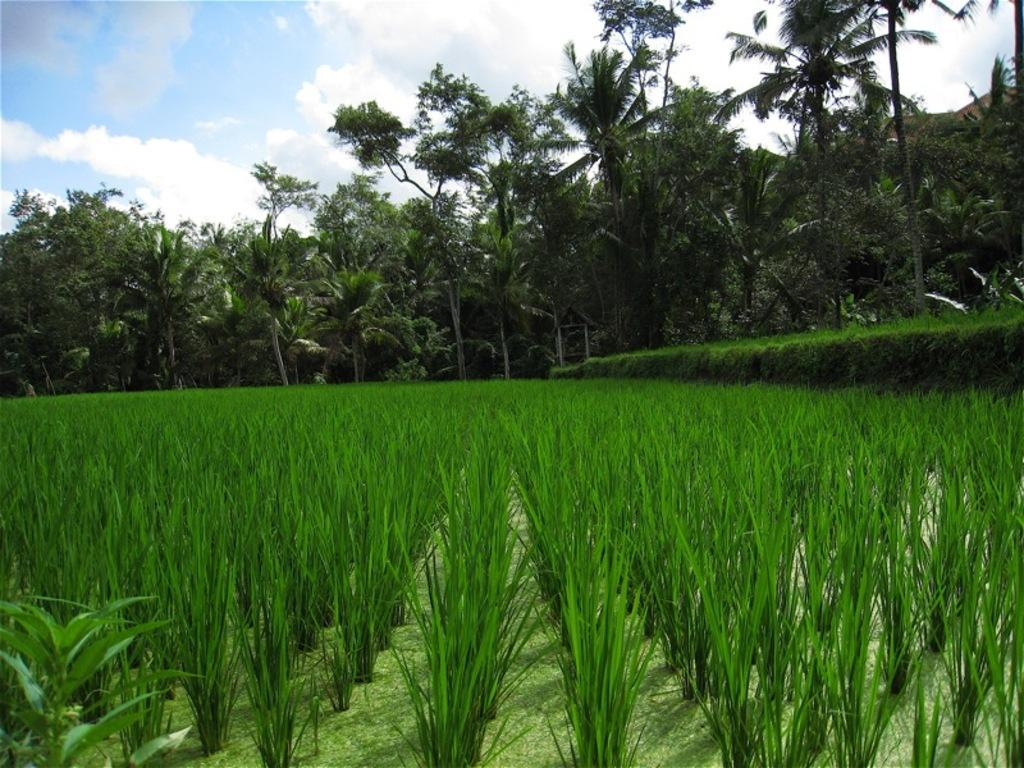What type of crop can be seen at the bottom of the image? There is a paddy crop at the bottom of the image. What else is present in the middle of the image? There are trees in the middle of the image. How would you describe the sky in the image? The sky is cloudy at the top of the image. Can you hear any songs being sung by the owl in the image? There is no owl present in the image, and therefore no songs can be heard. How does the paddy crop stretch towards the sky in the image? The paddy crop does not stretch towards the sky in the image; it is stationary at the bottom of the image. 